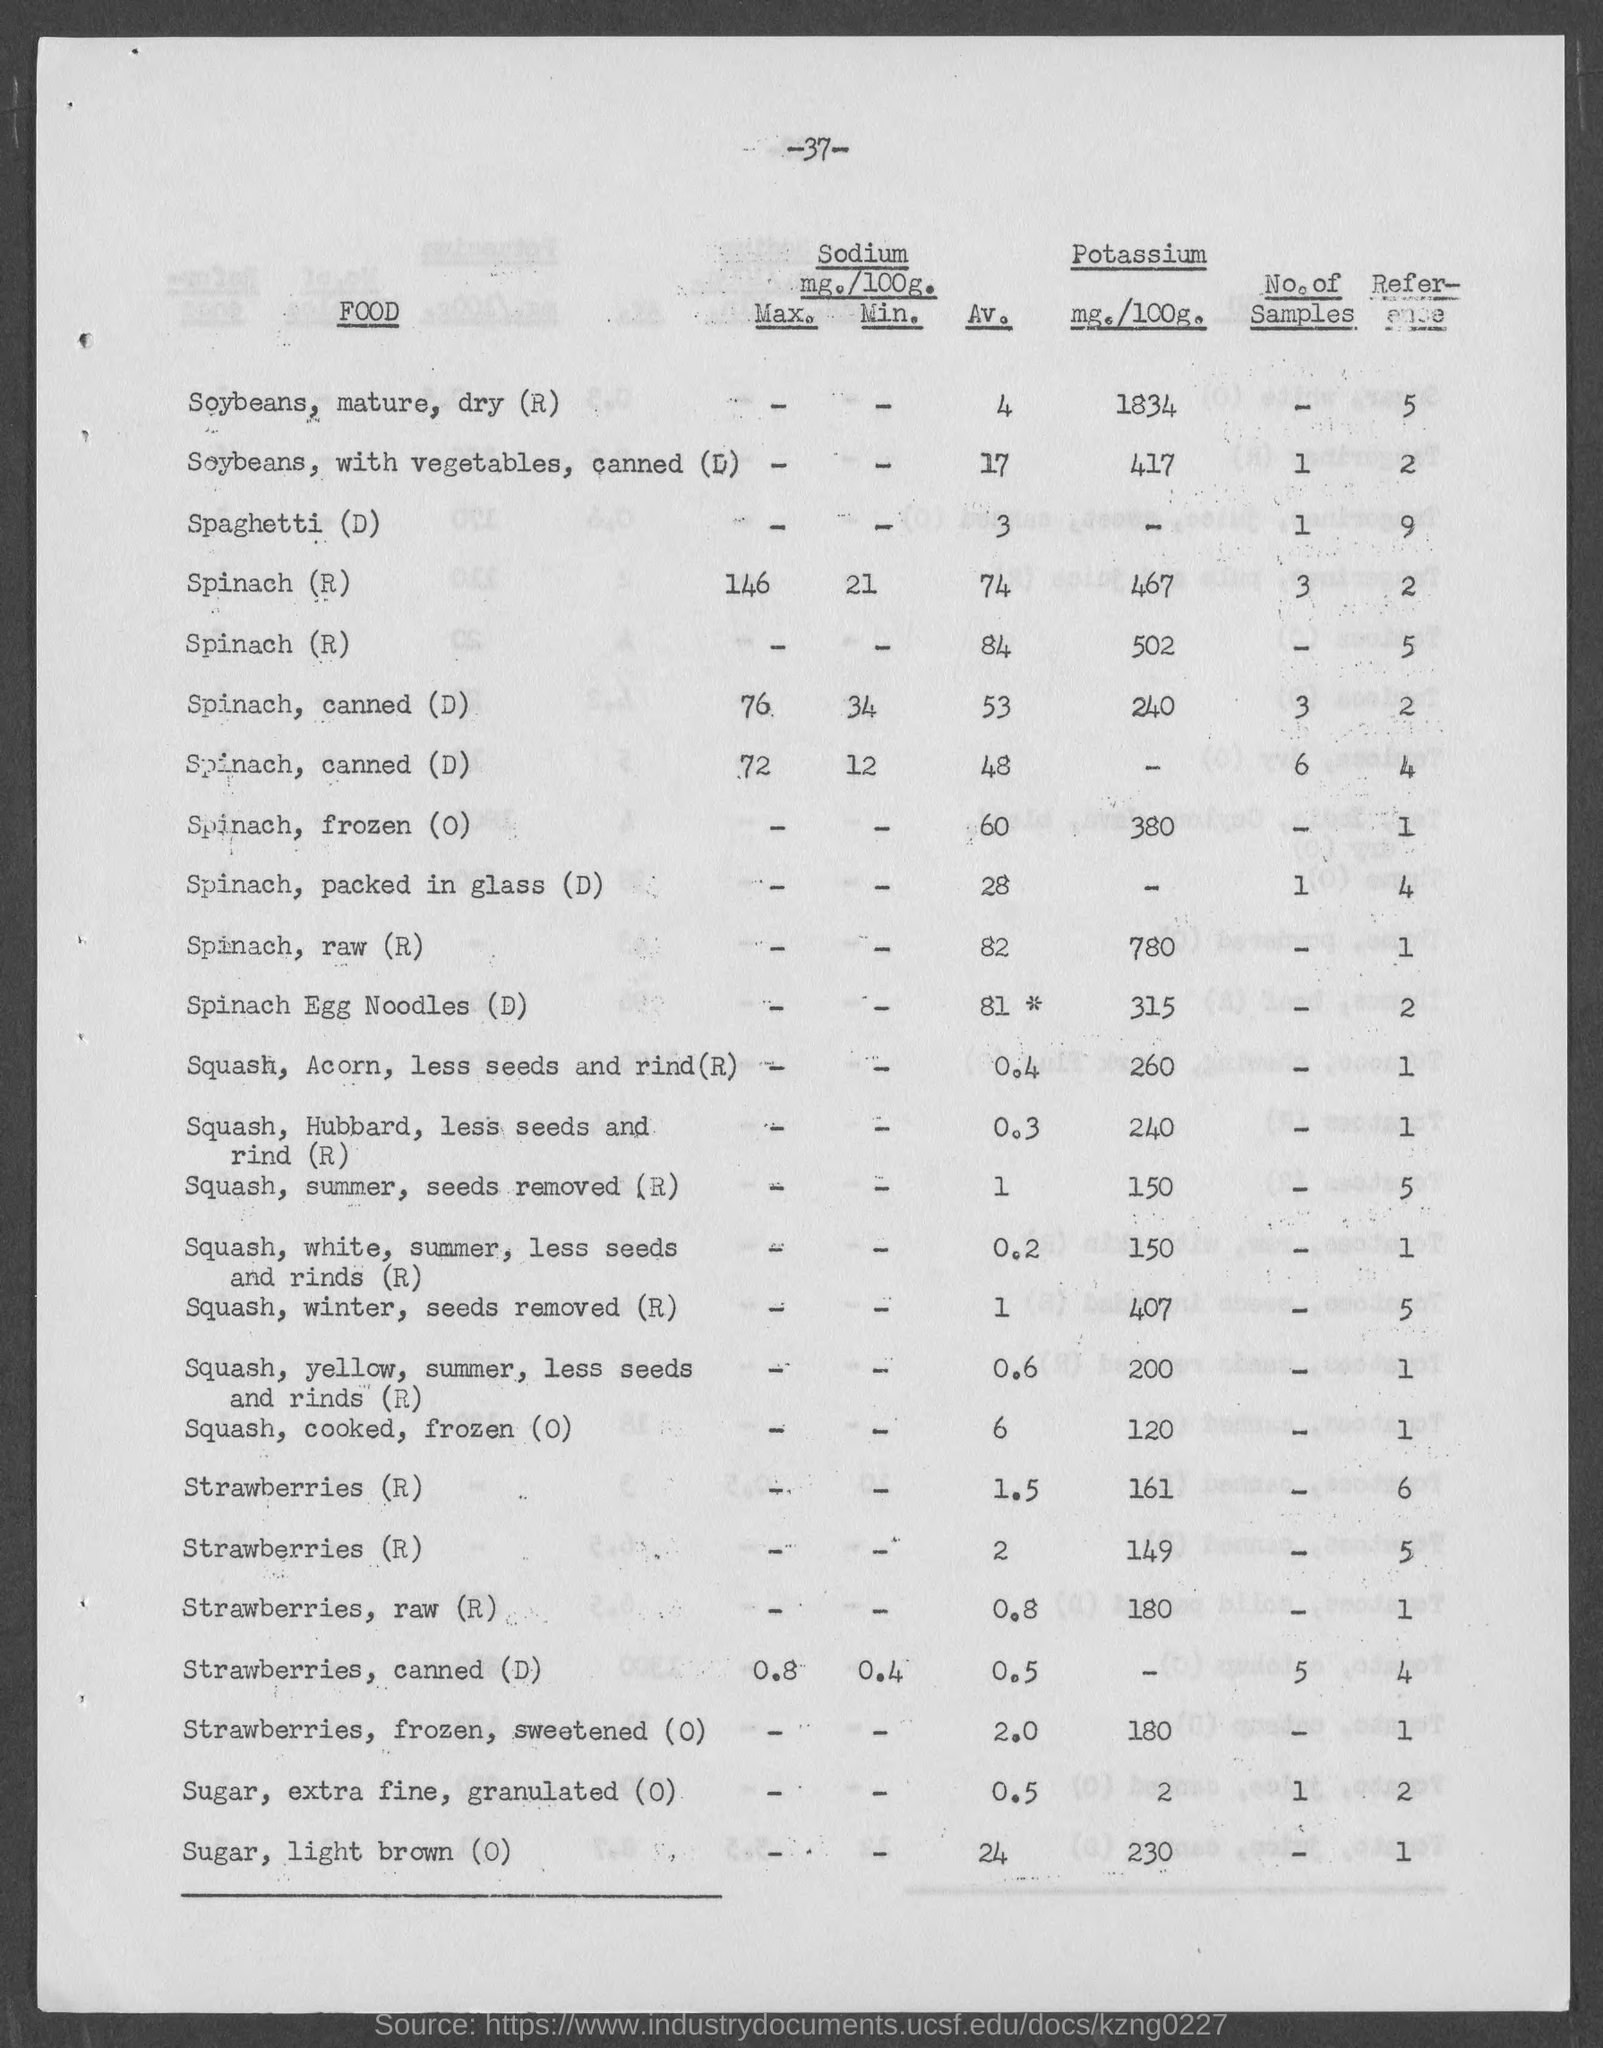what is the amount of Potassium mg./100g. for Squash, Winter, seeds removed? The Squash, Winter, with the seeds removed contains 407 mg of Potassium per 100 grams. This macro mineral is integral for various bodily functions, including fluid balance and muscle contractions. 